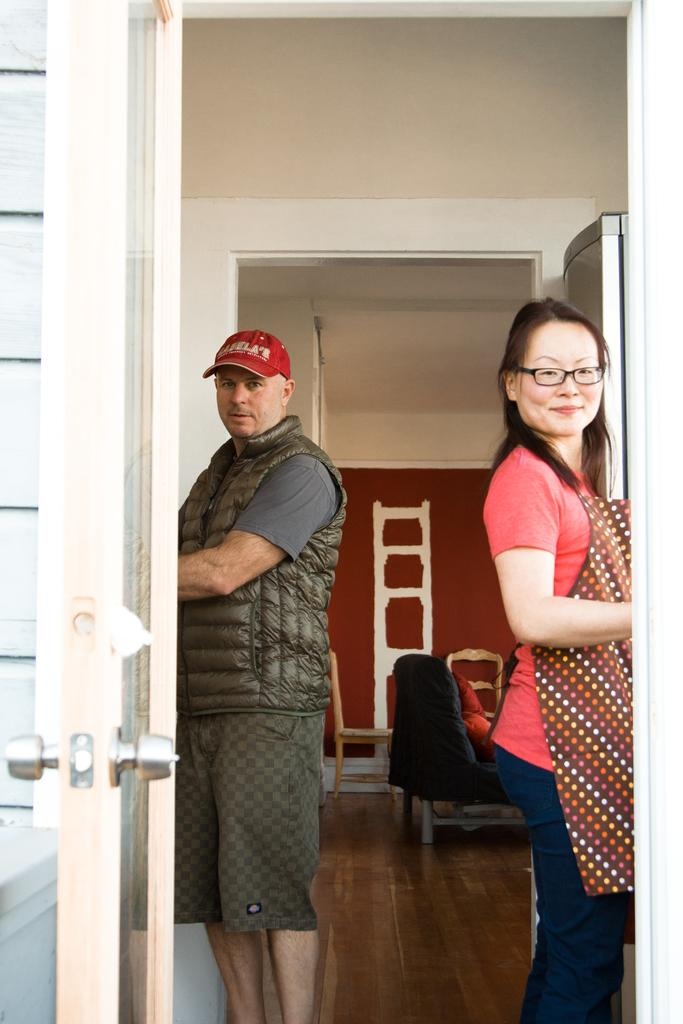Who is on the left side of the image? There is a man on the left side of the image. Who is on the right side of the image? There is a woman on the right side of the image. What can be seen in the background of the image? There is a door, a chair, and a wall in the background of the image. What type of market is depicted in the image? There is no market present in the image; it features a man on the left side and a woman on the right side, along with a door, chair, and wall in the background. 